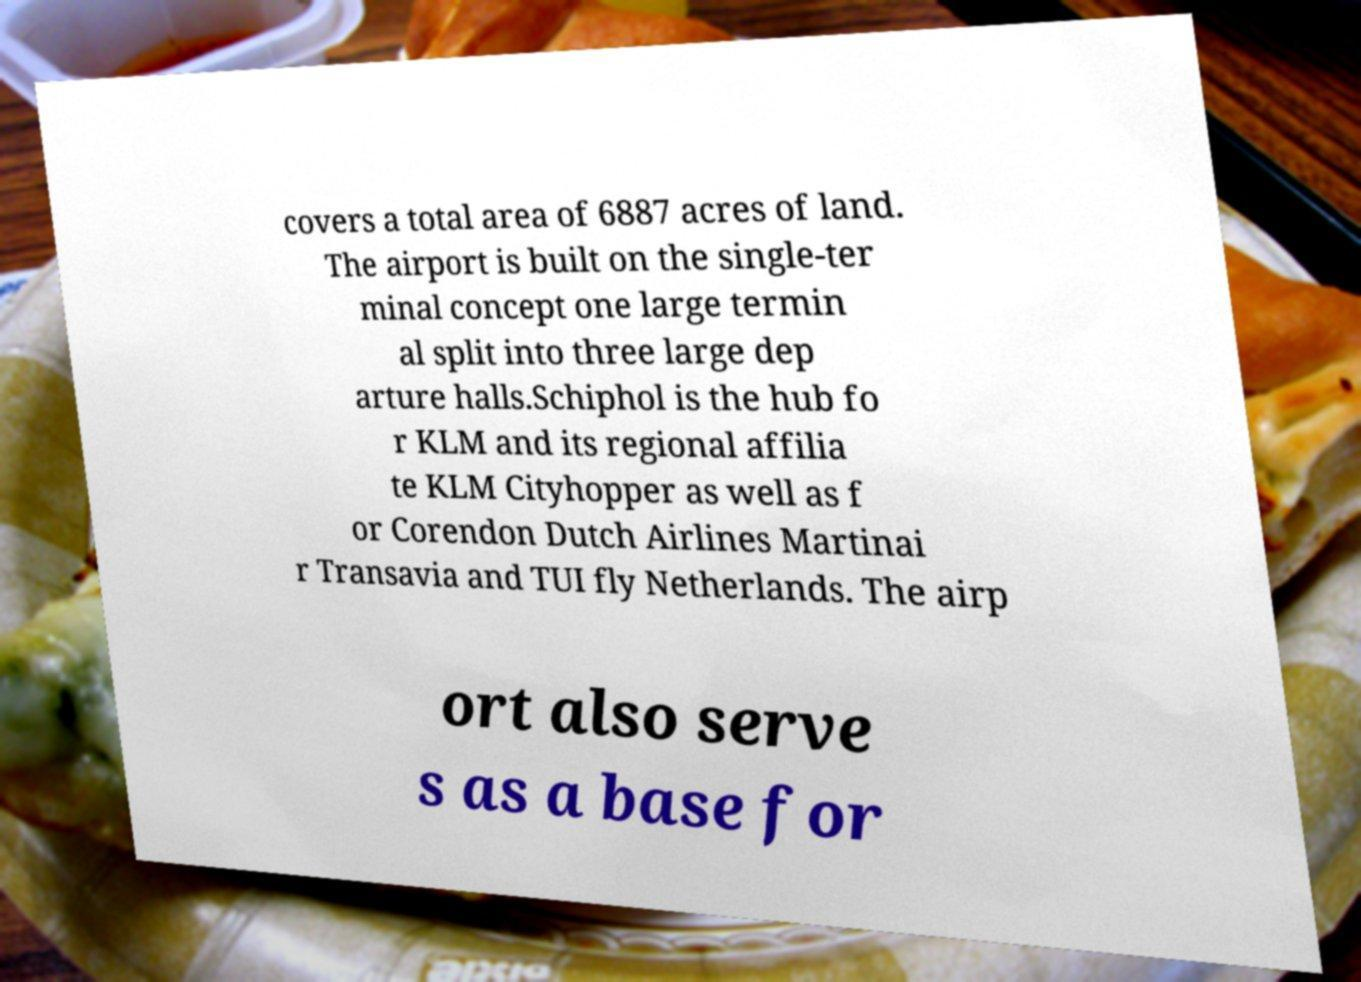There's text embedded in this image that I need extracted. Can you transcribe it verbatim? covers a total area of 6887 acres of land. The airport is built on the single-ter minal concept one large termin al split into three large dep arture halls.Schiphol is the hub fo r KLM and its regional affilia te KLM Cityhopper as well as f or Corendon Dutch Airlines Martinai r Transavia and TUI fly Netherlands. The airp ort also serve s as a base for 